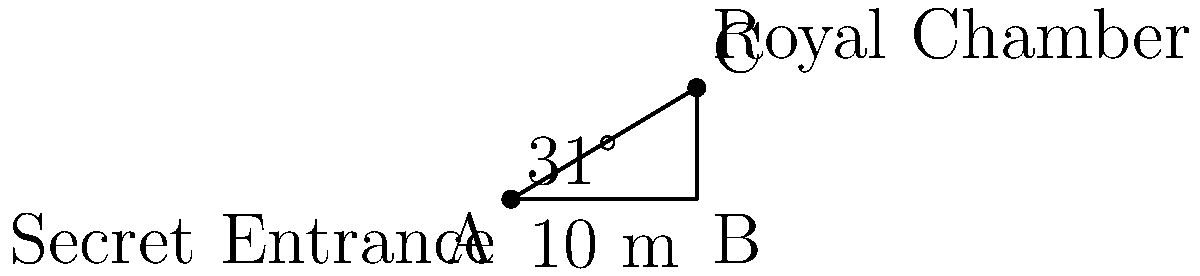As part of your investigation into royal scandals, you've discovered a secret tunnel connecting two chambers in an ancient palace. The entrance to the tunnel is at ground level (point A), and it leads to a royal chamber (point C) in a tower. The horizontal distance from the tunnel entrance to the base of the tower (point B) is 10 meters. The angle of elevation from the tunnel entrance to the royal chamber is 31°. What is the length of the secret tunnel to the nearest tenth of a meter? To find the length of the secret tunnel, we need to use trigonometry. Let's approach this step-by-step:

1) The secret tunnel forms the hypotenuse of a right-angled triangle ABC.

2) We know:
   - The adjacent side (AB) = 10 meters
   - The angle of elevation = 31°

3) We need to find the length of AC (the hypotenuse).

4) We can use the cosine function:

   $\cos \theta = \frac{\text{adjacent}}{\text{hypotenuse}}$

5) Substituting our values:

   $\cos 31° = \frac{10}{\text{hypotenuse}}$

6) Rearranging to solve for the hypotenuse:

   $\text{hypotenuse} = \frac{10}{\cos 31°}$

7) Using a calculator:

   $\text{hypotenuse} = \frac{10}{\cos 31°} \approx 11.66$ meters

8) Rounding to the nearest tenth:

   $\text{hypotenuse} \approx 11.7$ meters

Therefore, the length of the secret tunnel is approximately 11.7 meters.
Answer: 11.7 meters 